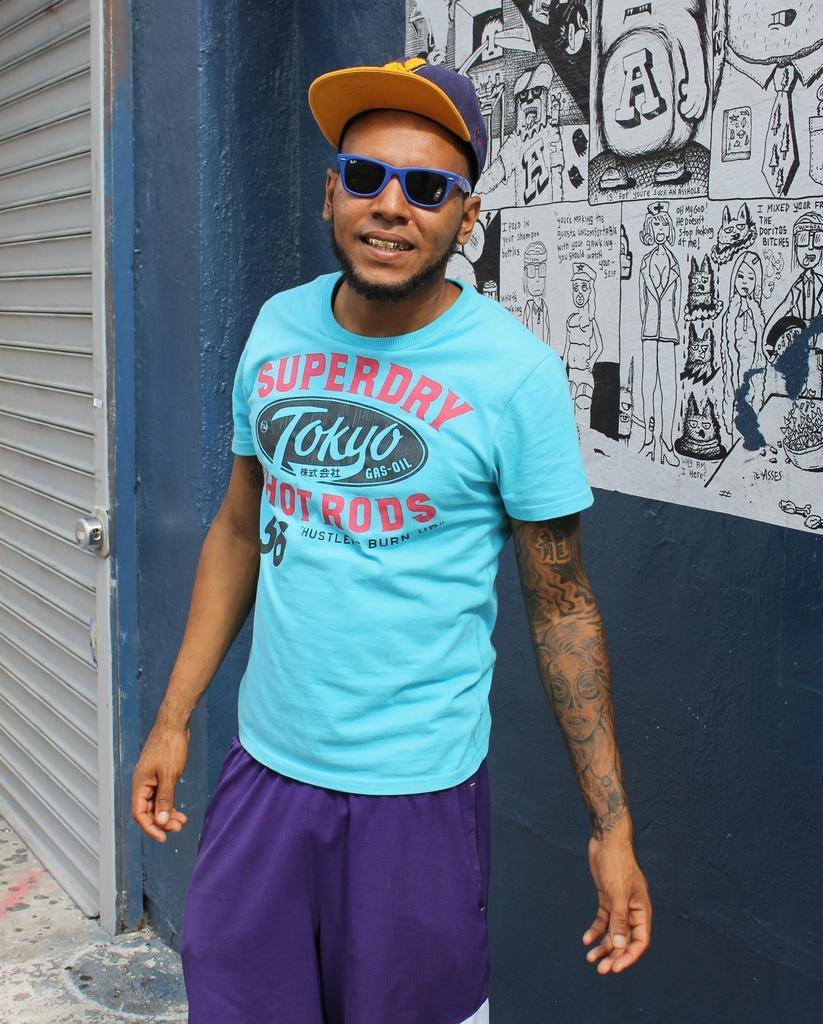In one or two sentences, can you explain what this image depicts? In this image I can see a man is standing in the front. I can see he is wearing t shirt, purple colour paint, shades and a cap. On his t shirt I can see something is written and in the background I can see painting of cartoon characters on the wall. On the left side of this image I can see a white colour shutter. 